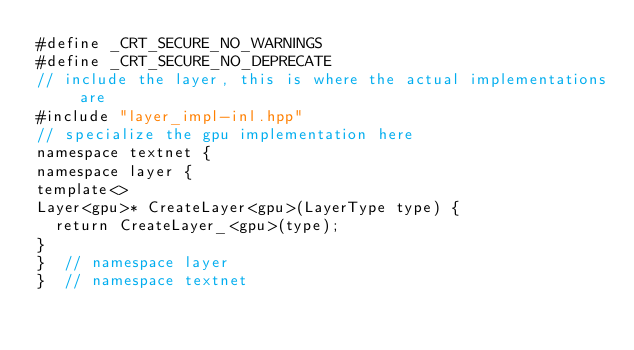<code> <loc_0><loc_0><loc_500><loc_500><_Cuda_>#define _CRT_SECURE_NO_WARNINGS
#define _CRT_SECURE_NO_DEPRECATE
// include the layer, this is where the actual implementations are
#include "layer_impl-inl.hpp"
// specialize the gpu implementation here
namespace textnet {
namespace layer {
template<>
Layer<gpu>* CreateLayer<gpu>(LayerType type) {
  return CreateLayer_<gpu>(type); 
}
}  // namespace layer
}  // namespace textnet

</code> 